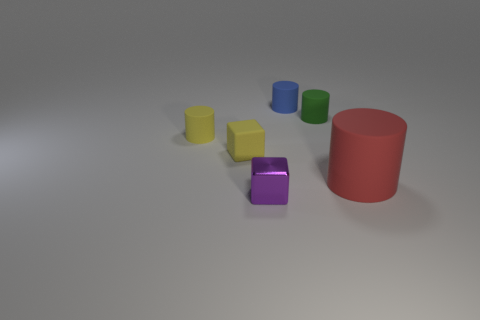How many objects are in front of the yellow thing right of the small yellow matte cylinder?
Give a very brief answer. 2. There is a rubber cylinder that is in front of the tiny yellow cylinder behind the object that is in front of the large red matte cylinder; how big is it?
Your response must be concise. Large. What color is the tiny matte object in front of the matte cylinder that is left of the small rubber block?
Provide a short and direct response. Yellow. How many other objects are the same material as the large red cylinder?
Keep it short and to the point. 4. How many other objects are the same color as the small matte block?
Give a very brief answer. 1. There is a small thing in front of the cube that is behind the shiny cube; what is its material?
Your answer should be very brief. Metal. Is there a large red rubber thing?
Offer a terse response. Yes. There is a cube that is right of the yellow matte object that is in front of the tiny yellow cylinder; what size is it?
Keep it short and to the point. Small. Are there more small rubber blocks on the right side of the red rubber object than tiny cubes behind the tiny purple object?
Your response must be concise. No. What number of blocks are either big blue things or large red matte objects?
Provide a succinct answer. 0. 